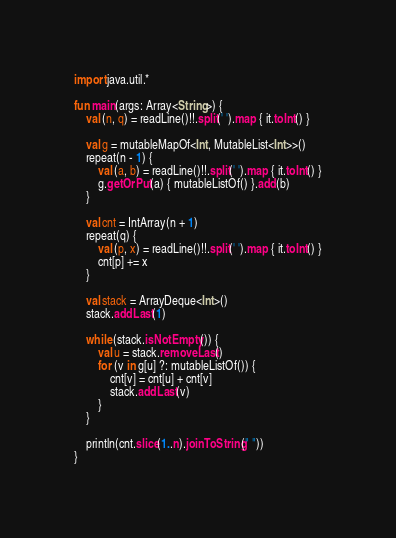Convert code to text. <code><loc_0><loc_0><loc_500><loc_500><_Kotlin_>import java.util.*

fun main(args: Array<String>) {
    val (n, q) = readLine()!!.split(' ').map { it.toInt() }

    val g = mutableMapOf<Int, MutableList<Int>>()
    repeat(n - 1) {
        val (a, b) = readLine()!!.split(' ').map { it.toInt() }
        g.getOrPut(a) { mutableListOf() }.add(b)
    }

    val cnt = IntArray(n + 1)
    repeat(q) {
        val (p, x) = readLine()!!.split(' ').map { it.toInt() }
        cnt[p] += x
    }

    val stack = ArrayDeque<Int>()
    stack.addLast(1)

    while (stack.isNotEmpty()) {
        val u = stack.removeLast()
        for (v in g[u] ?: mutableListOf()) {
            cnt[v] = cnt[u] + cnt[v]
            stack.addLast(v)
        }
    }

    println(cnt.slice(1..n).joinToString(" "))
}
</code> 